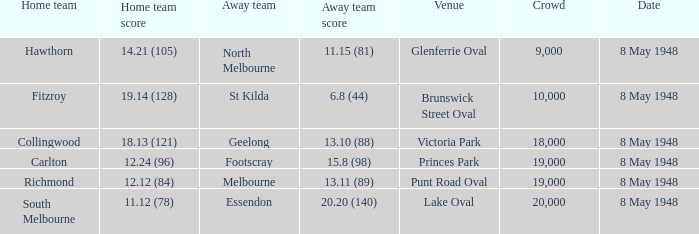Which opposing team played the home team when they reached 1 North Melbourne. Would you mind parsing the complete table? {'header': ['Home team', 'Home team score', 'Away team', 'Away team score', 'Venue', 'Crowd', 'Date'], 'rows': [['Hawthorn', '14.21 (105)', 'North Melbourne', '11.15 (81)', 'Glenferrie Oval', '9,000', '8 May 1948'], ['Fitzroy', '19.14 (128)', 'St Kilda', '6.8 (44)', 'Brunswick Street Oval', '10,000', '8 May 1948'], ['Collingwood', '18.13 (121)', 'Geelong', '13.10 (88)', 'Victoria Park', '18,000', '8 May 1948'], ['Carlton', '12.24 (96)', 'Footscray', '15.8 (98)', 'Princes Park', '19,000', '8 May 1948'], ['Richmond', '12.12 (84)', 'Melbourne', '13.11 (89)', 'Punt Road Oval', '19,000', '8 May 1948'], ['South Melbourne', '11.12 (78)', 'Essendon', '20.20 (140)', 'Lake Oval', '20,000', '8 May 1948']]} 